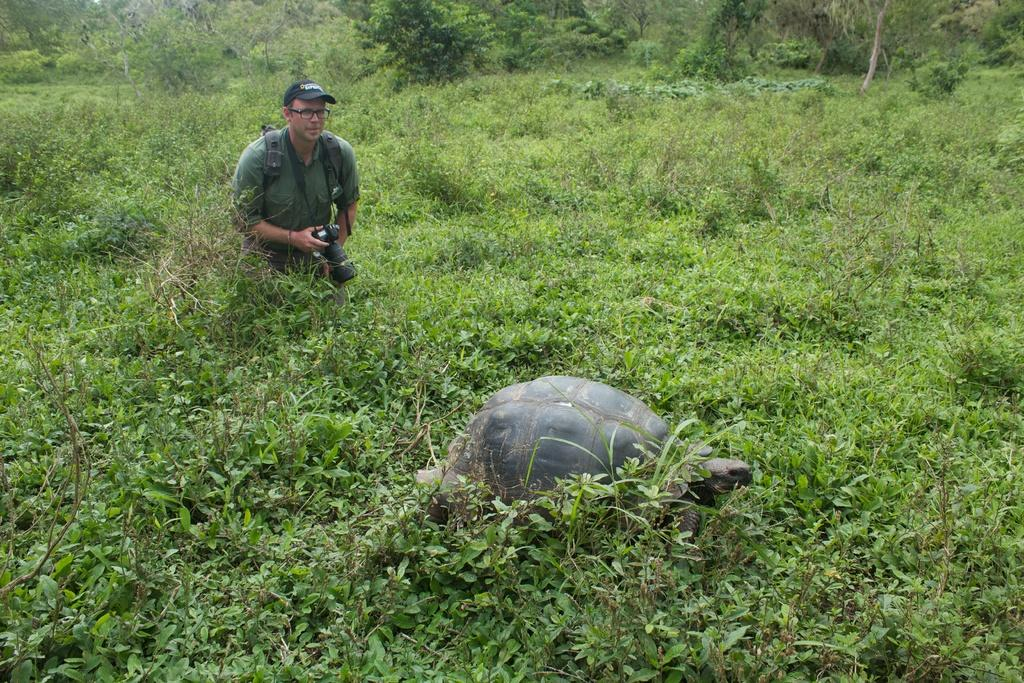What animal is present in the picture? There is a tortoise in the picture. What is the person in the picture doing? The person is holding a camera in the picture. What is the position of the person in the picture? The person is standing. What can be seen in the background of the picture? There are plants and trees in the background of the picture. How many moms are visible in the picture? There is no mom present in the picture; it features a tortoise and a person holding a camera. What type of snails can be seen interacting with the tortoise in the picture? There are no snails present in the picture; it only features a tortoise and a person holding a camera. 